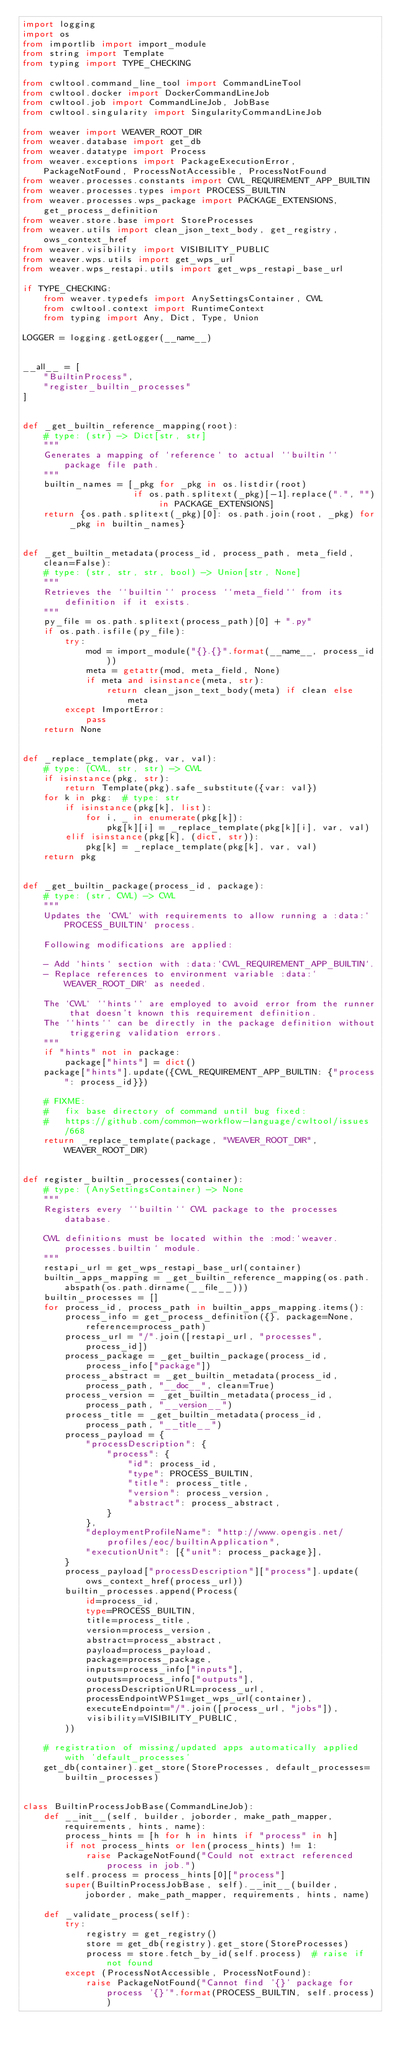<code> <loc_0><loc_0><loc_500><loc_500><_Python_>import logging
import os
from importlib import import_module
from string import Template
from typing import TYPE_CHECKING

from cwltool.command_line_tool import CommandLineTool
from cwltool.docker import DockerCommandLineJob
from cwltool.job import CommandLineJob, JobBase
from cwltool.singularity import SingularityCommandLineJob

from weaver import WEAVER_ROOT_DIR
from weaver.database import get_db
from weaver.datatype import Process
from weaver.exceptions import PackageExecutionError, PackageNotFound, ProcessNotAccessible, ProcessNotFound
from weaver.processes.constants import CWL_REQUIREMENT_APP_BUILTIN
from weaver.processes.types import PROCESS_BUILTIN
from weaver.processes.wps_package import PACKAGE_EXTENSIONS, get_process_definition
from weaver.store.base import StoreProcesses
from weaver.utils import clean_json_text_body, get_registry, ows_context_href
from weaver.visibility import VISIBILITY_PUBLIC
from weaver.wps.utils import get_wps_url
from weaver.wps_restapi.utils import get_wps_restapi_base_url

if TYPE_CHECKING:
    from weaver.typedefs import AnySettingsContainer, CWL
    from cwltool.context import RuntimeContext
    from typing import Any, Dict, Type, Union

LOGGER = logging.getLogger(__name__)


__all__ = [
    "BuiltinProcess",
    "register_builtin_processes"
]


def _get_builtin_reference_mapping(root):
    # type: (str) -> Dict[str, str]
    """
    Generates a mapping of `reference` to actual ``builtin`` package file path.
    """
    builtin_names = [_pkg for _pkg in os.listdir(root)
                     if os.path.splitext(_pkg)[-1].replace(".", "") in PACKAGE_EXTENSIONS]
    return {os.path.splitext(_pkg)[0]: os.path.join(root, _pkg) for _pkg in builtin_names}


def _get_builtin_metadata(process_id, process_path, meta_field, clean=False):
    # type: (str, str, str, bool) -> Union[str, None]
    """
    Retrieves the ``builtin`` process ``meta_field`` from its definition if it exists.
    """
    py_file = os.path.splitext(process_path)[0] + ".py"
    if os.path.isfile(py_file):
        try:
            mod = import_module("{}.{}".format(__name__, process_id))
            meta = getattr(mod, meta_field, None)
            if meta and isinstance(meta, str):
                return clean_json_text_body(meta) if clean else meta
        except ImportError:
            pass
    return None


def _replace_template(pkg, var, val):
    # type: (CWL, str, str) -> CWL
    if isinstance(pkg, str):
        return Template(pkg).safe_substitute({var: val})
    for k in pkg:  # type: str
        if isinstance(pkg[k], list):
            for i, _ in enumerate(pkg[k]):
                pkg[k][i] = _replace_template(pkg[k][i], var, val)
        elif isinstance(pkg[k], (dict, str)):
            pkg[k] = _replace_template(pkg[k], var, val)
    return pkg


def _get_builtin_package(process_id, package):
    # type: (str, CWL) -> CWL
    """
    Updates the `CWL` with requirements to allow running a :data:`PROCESS_BUILTIN` process.

    Following modifications are applied:

    - Add `hints` section with :data:`CWL_REQUIREMENT_APP_BUILTIN`.
    - Replace references to environment variable :data:`WEAVER_ROOT_DIR` as needed.

    The `CWL` ``hints`` are employed to avoid error from the runner that doesn't known this requirement definition.
    The ``hints`` can be directly in the package definition without triggering validation errors.
    """
    if "hints" not in package:
        package["hints"] = dict()
    package["hints"].update({CWL_REQUIREMENT_APP_BUILTIN: {"process": process_id}})

    # FIXME:
    #   fix base directory of command until bug fixed:
    #   https://github.com/common-workflow-language/cwltool/issues/668
    return _replace_template(package, "WEAVER_ROOT_DIR", WEAVER_ROOT_DIR)


def register_builtin_processes(container):
    # type: (AnySettingsContainer) -> None
    """
    Registers every ``builtin`` CWL package to the processes database.

    CWL definitions must be located within the :mod:`weaver.processes.builtin` module.
    """
    restapi_url = get_wps_restapi_base_url(container)
    builtin_apps_mapping = _get_builtin_reference_mapping(os.path.abspath(os.path.dirname(__file__)))
    builtin_processes = []
    for process_id, process_path in builtin_apps_mapping.items():
        process_info = get_process_definition({}, package=None, reference=process_path)
        process_url = "/".join([restapi_url, "processes", process_id])
        process_package = _get_builtin_package(process_id, process_info["package"])
        process_abstract = _get_builtin_metadata(process_id, process_path, "__doc__", clean=True)
        process_version = _get_builtin_metadata(process_id, process_path, "__version__")
        process_title = _get_builtin_metadata(process_id, process_path, "__title__")
        process_payload = {
            "processDescription": {
                "process": {
                    "id": process_id,
                    "type": PROCESS_BUILTIN,
                    "title": process_title,
                    "version": process_version,
                    "abstract": process_abstract,
                }
            },
            "deploymentProfileName": "http://www.opengis.net/profiles/eoc/builtinApplication",
            "executionUnit": [{"unit": process_package}],
        }
        process_payload["processDescription"]["process"].update(ows_context_href(process_url))
        builtin_processes.append(Process(
            id=process_id,
            type=PROCESS_BUILTIN,
            title=process_title,
            version=process_version,
            abstract=process_abstract,
            payload=process_payload,
            package=process_package,
            inputs=process_info["inputs"],
            outputs=process_info["outputs"],
            processDescriptionURL=process_url,
            processEndpointWPS1=get_wps_url(container),
            executeEndpoint="/".join([process_url, "jobs"]),
            visibility=VISIBILITY_PUBLIC,
        ))

    # registration of missing/updated apps automatically applied with 'default_processes'
    get_db(container).get_store(StoreProcesses, default_processes=builtin_processes)


class BuiltinProcessJobBase(CommandLineJob):
    def __init__(self, builder, joborder, make_path_mapper, requirements, hints, name):
        process_hints = [h for h in hints if "process" in h]
        if not process_hints or len(process_hints) != 1:
            raise PackageNotFound("Could not extract referenced process in job.")
        self.process = process_hints[0]["process"]
        super(BuiltinProcessJobBase, self).__init__(builder, joborder, make_path_mapper, requirements, hints, name)

    def _validate_process(self):
        try:
            registry = get_registry()
            store = get_db(registry).get_store(StoreProcesses)
            process = store.fetch_by_id(self.process)  # raise if not found
        except (ProcessNotAccessible, ProcessNotFound):
            raise PackageNotFound("Cannot find '{}' package for process '{}'".format(PROCESS_BUILTIN, self.process))</code> 